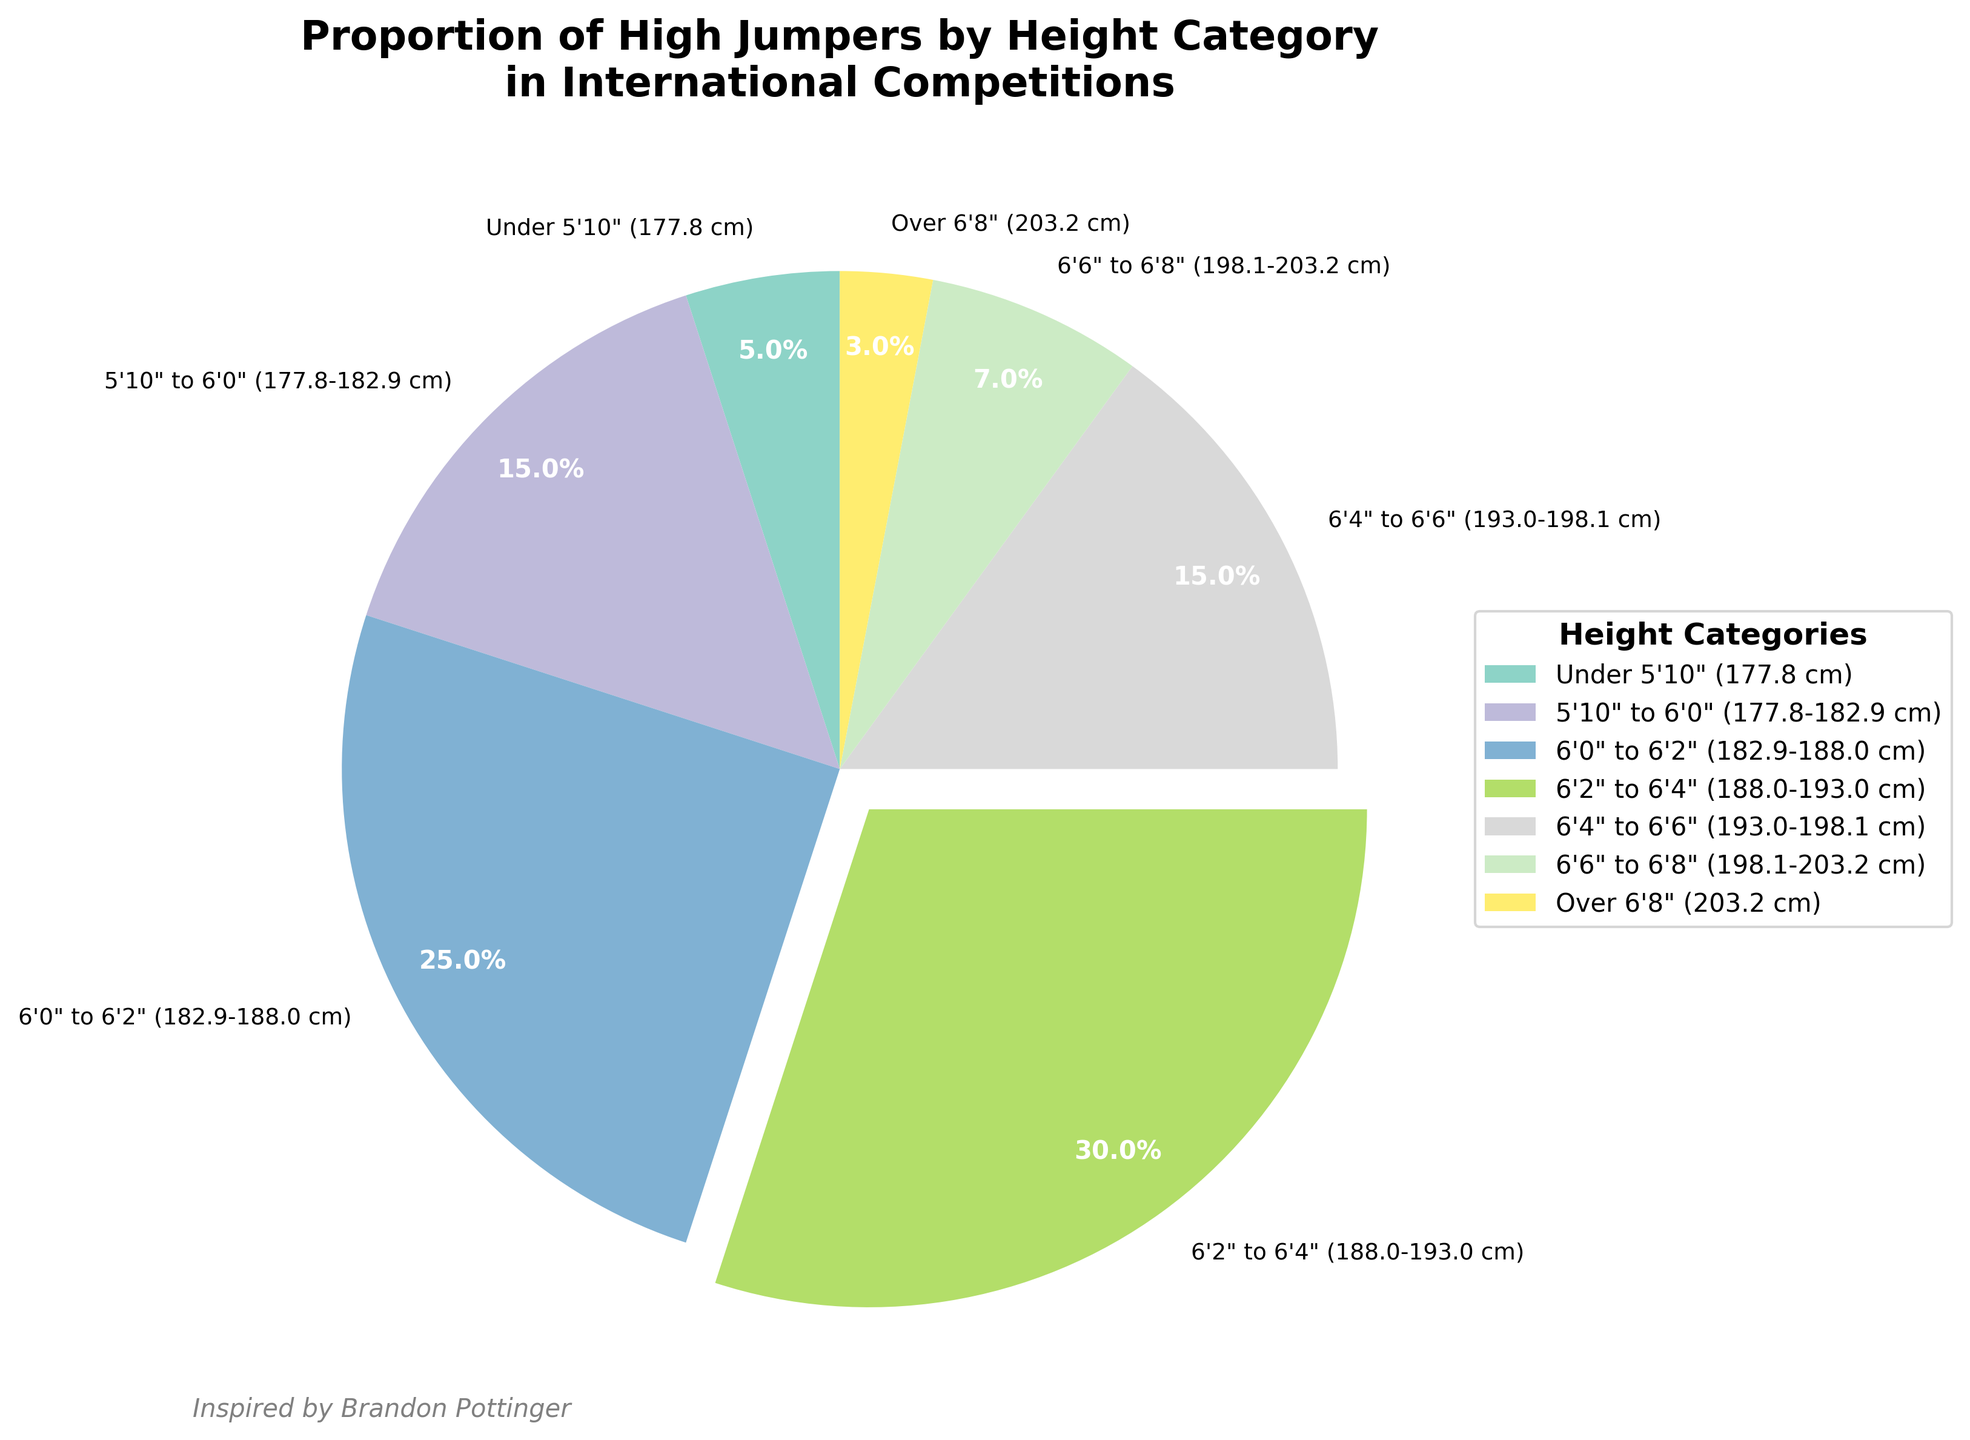What is the most common height category for high jumpers in international competitions? The height category with the largest proportion in the pie chart is the one that occupies the largest segment. The category "6'2" to 6'4" (188.0-193.0 cm)" has the largest segment with 30%.
Answer: 6'2" to 6'4" (188.0-193.0 cm) What is the total proportion of high jumpers who are under 6'0"? To find the total proportion, sum up the percentages of the categories "Under 5'10" (177.8 cm)" and "5'10" to 6'0" (177.8-182.9 cm)". That’s 0.05 + 0.15 = 0.20 or 20%.
Answer: 20% What is the difference in proportion between the tallest (over 6'8") and the shortest (under 5'10") height categories? Subtract the proportion of the "Under 5'10"" category from the "Over 6'8"" category. That’s 0.05 - 0.03 = 0.02 or 2%.
Answer: 2% How does the proportion of high jumpers who are 6'4" to 6'6" compare to those who are 5'10" to 6'0"? The proportion for height category "6'4" to 6'6"" is 0.15, which is the same as the proportion for "5'10" to 6'0"". So, they are equal.
Answer: Equal Which color represents the smallest proportion of high jumpers and what is that category? The smallest segment in the pie chart, representing 3%, is the "Over 6'8"" (203.2 cm) category.
Answer: Over 6'8" (203.2 cm) What visual feature highlights the most common height category in the pie chart? The most common height category is separated slightly (exploded) from the rest of the pie chart to highlight it visually. This category is "6'2" to 6'4" (188.0-193.0 cm)".
Answer: Exploded segment What is the combined proportion of high jumpers who are between 6'0" and 6'6"? Sum the proportions of the "6'0" to 6'2"" and "6'2" to 6'4"" and "6'4" to 6'6"" categories. That’s 0.25 + 0.30 + 0.15 = 0.70 or 70%.
Answer: 70% Which height category covers twice the proportion of the "6'6" to 6'8"" category? The "6'6" to 6'8"" category has 7%. The category with twice this proportion is the "6'0" to 6'2"" category, which has 25%.
Answer: 6'0" to 6'2" (182.9-188.0 cm) How would you interpret the text "Inspired by Brandon Pottinger" that appears in the pie chart? The text suggests that Brandon Pottinger served as an inspiration for the creation of the chart, providing a motivational or thematic influence.
Answer: Inspired by Brandon Pottinger 